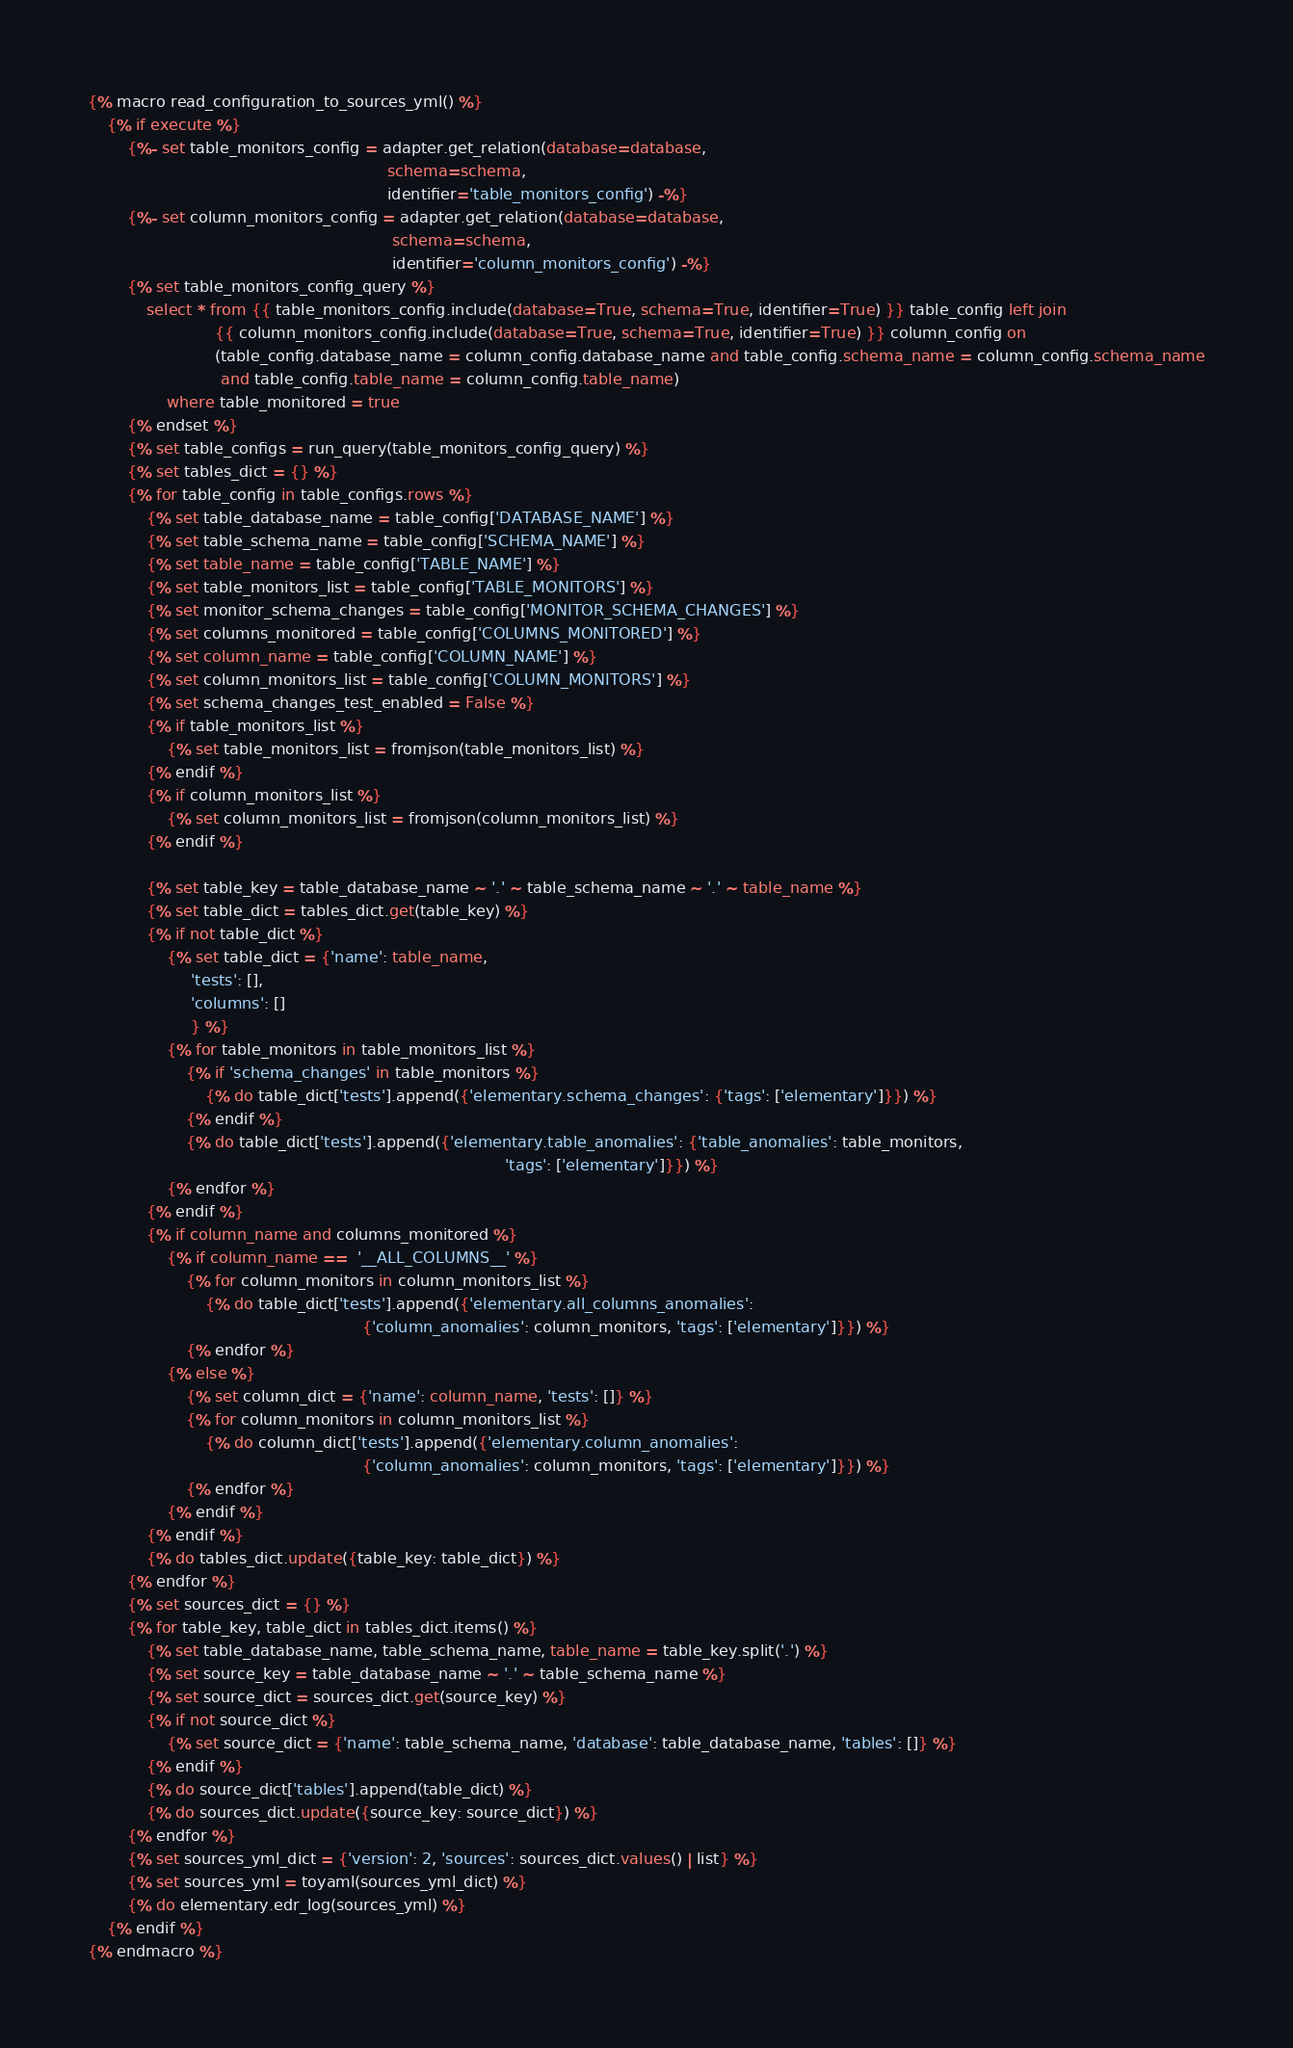Convert code to text. <code><loc_0><loc_0><loc_500><loc_500><_SQL_>{% macro read_configuration_to_sources_yml() %}
    {% if execute %}
        {%- set table_monitors_config = adapter.get_relation(database=database,
                                                             schema=schema,
                                                             identifier='table_monitors_config') -%}
        {%- set column_monitors_config = adapter.get_relation(database=database,
                                                              schema=schema,
                                                              identifier='column_monitors_config') -%}
        {% set table_monitors_config_query %}
            select * from {{ table_monitors_config.include(database=True, schema=True, identifier=True) }} table_config left join
                          {{ column_monitors_config.include(database=True, schema=True, identifier=True) }} column_config on
                          (table_config.database_name = column_config.database_name and table_config.schema_name = column_config.schema_name
                           and table_config.table_name = column_config.table_name)
                where table_monitored = true
        {% endset %}
        {% set table_configs = run_query(table_monitors_config_query) %}
        {% set tables_dict = {} %}
        {% for table_config in table_configs.rows %}
            {% set table_database_name = table_config['DATABASE_NAME'] %}
            {% set table_schema_name = table_config['SCHEMA_NAME'] %}
            {% set table_name = table_config['TABLE_NAME'] %}
            {% set table_monitors_list = table_config['TABLE_MONITORS'] %}
            {% set monitor_schema_changes = table_config['MONITOR_SCHEMA_CHANGES'] %}
            {% set columns_monitored = table_config['COLUMNS_MONITORED'] %}
            {% set column_name = table_config['COLUMN_NAME'] %}
            {% set column_monitors_list = table_config['COLUMN_MONITORS'] %}
            {% set schema_changes_test_enabled = False %}
            {% if table_monitors_list %}
                {% set table_monitors_list = fromjson(table_monitors_list) %}
            {% endif %}
            {% if column_monitors_list %}
                {% set column_monitors_list = fromjson(column_monitors_list) %}
            {% endif %}

            {% set table_key = table_database_name ~ '.' ~ table_schema_name ~ '.' ~ table_name %}
            {% set table_dict = tables_dict.get(table_key) %}
            {% if not table_dict %}
                {% set table_dict = {'name': table_name,
                     'tests': [],
                     'columns': []
                     } %}
                {% for table_monitors in table_monitors_list %}
                    {% if 'schema_changes' in table_monitors %}
                        {% do table_dict['tests'].append({'elementary.schema_changes': {'tags': ['elementary']}}) %}
                    {% endif %}
                    {% do table_dict['tests'].append({'elementary.table_anomalies': {'table_anomalies': table_monitors,
                                                                                     'tags': ['elementary']}}) %}
                {% endfor %}
            {% endif %}
            {% if column_name and columns_monitored %}
                {% if column_name ==  '__ALL_COLUMNS__' %}
                    {% for column_monitors in column_monitors_list %}
                        {% do table_dict['tests'].append({'elementary.all_columns_anomalies':
                                                        {'column_anomalies': column_monitors, 'tags': ['elementary']}}) %}
                    {% endfor %}
                {% else %}
                    {% set column_dict = {'name': column_name, 'tests': []} %}
                    {% for column_monitors in column_monitors_list %}
                        {% do column_dict['tests'].append({'elementary.column_anomalies':
                                                        {'column_anomalies': column_monitors, 'tags': ['elementary']}}) %}
                    {% endfor %}
                {% endif %}
            {% endif %}
            {% do tables_dict.update({table_key: table_dict}) %}
        {% endfor %}
        {% set sources_dict = {} %}
        {% for table_key, table_dict in tables_dict.items() %}
            {% set table_database_name, table_schema_name, table_name = table_key.split('.') %}
            {% set source_key = table_database_name ~ '.' ~ table_schema_name %}
            {% set source_dict = sources_dict.get(source_key) %}
            {% if not source_dict %}
                {% set source_dict = {'name': table_schema_name, 'database': table_database_name, 'tables': []} %}
            {% endif %}
            {% do source_dict['tables'].append(table_dict) %}
            {% do sources_dict.update({source_key: source_dict}) %}
        {% endfor %}
        {% set sources_yml_dict = {'version': 2, 'sources': sources_dict.values() | list} %}
        {% set sources_yml = toyaml(sources_yml_dict) %}
        {% do elementary.edr_log(sources_yml) %}
    {% endif %}
{% endmacro %}
</code> 